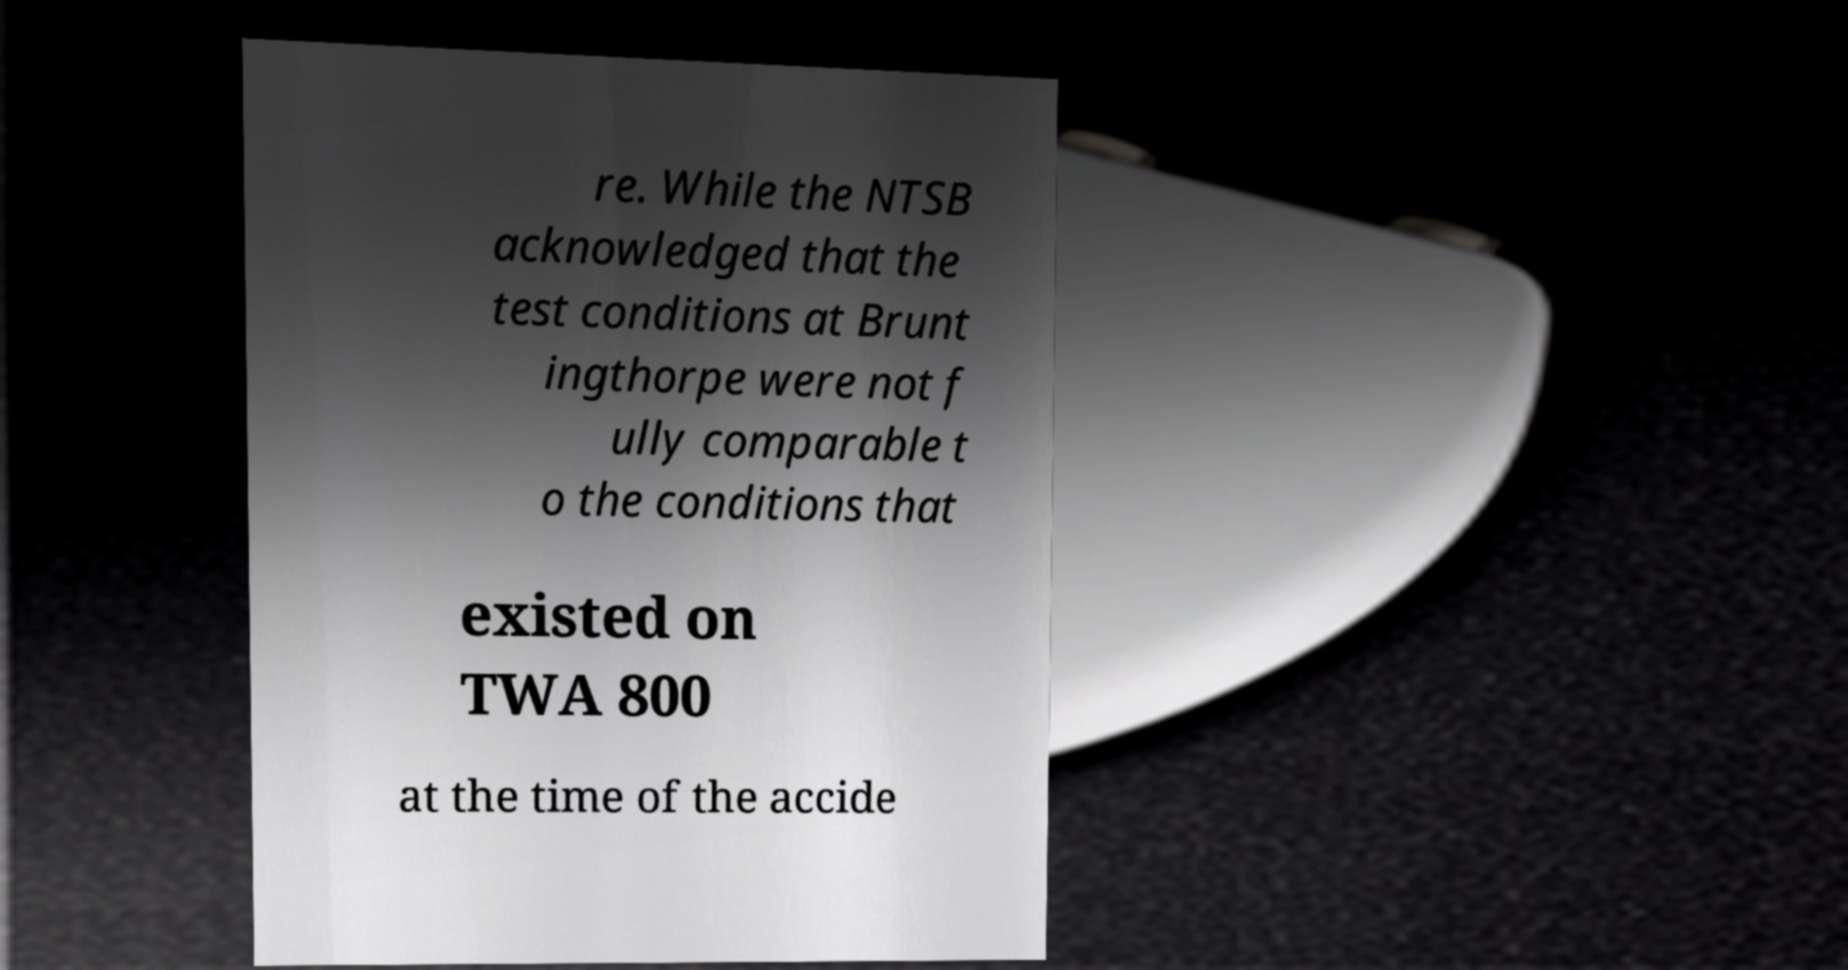What messages or text are displayed in this image? I need them in a readable, typed format. re. While the NTSB acknowledged that the test conditions at Brunt ingthorpe were not f ully comparable t o the conditions that existed on TWA 800 at the time of the accide 